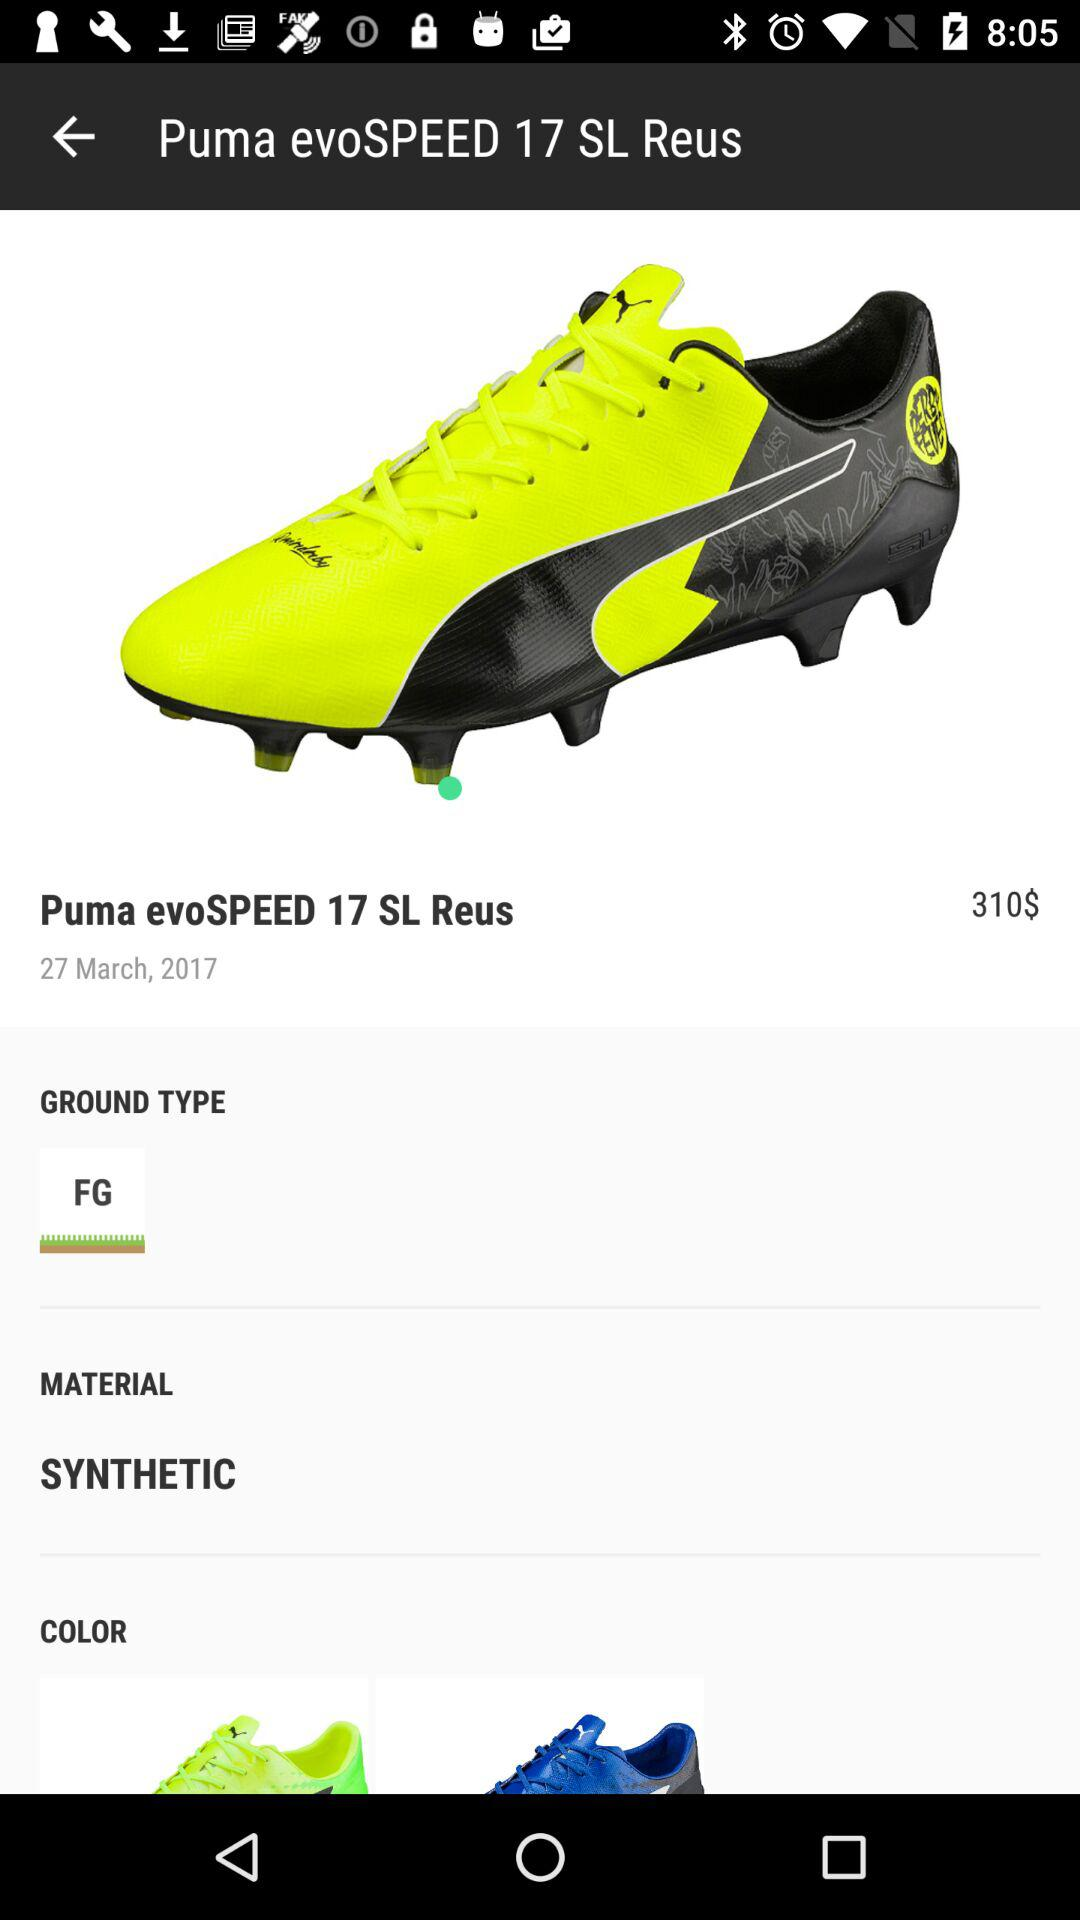What is the price of the shoe? The price is 310$. 